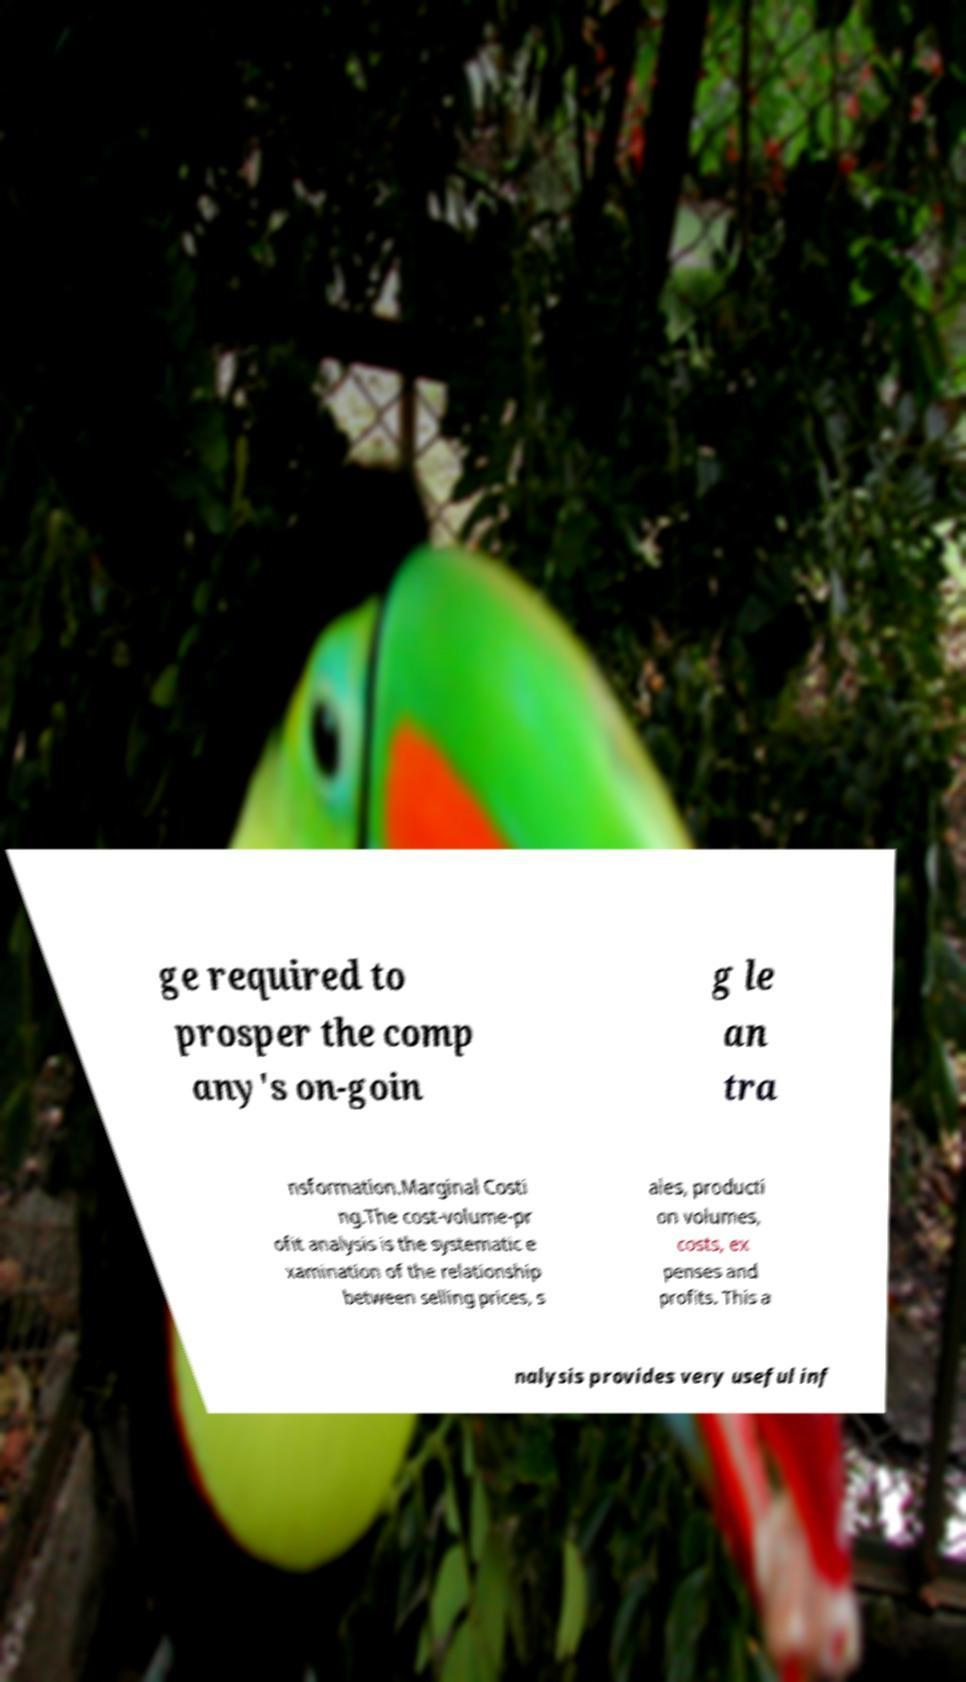What messages or text are displayed in this image? I need them in a readable, typed format. ge required to prosper the comp any's on-goin g le an tra nsformation.Marginal Costi ng.The cost-volume-pr ofit analysis is the systematic e xamination of the relationship between selling prices, s ales, producti on volumes, costs, ex penses and profits. This a nalysis provides very useful inf 